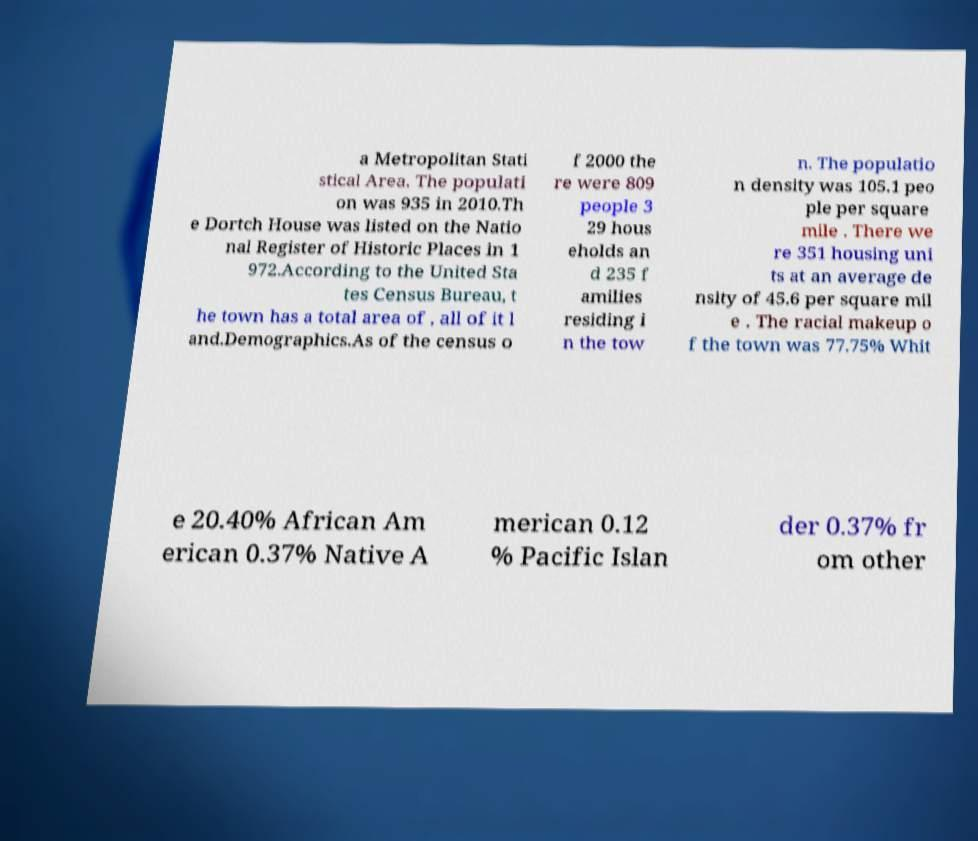Could you extract and type out the text from this image? a Metropolitan Stati stical Area. The populati on was 935 in 2010.Th e Dortch House was listed on the Natio nal Register of Historic Places in 1 972.According to the United Sta tes Census Bureau, t he town has a total area of , all of it l and.Demographics.As of the census o f 2000 the re were 809 people 3 29 hous eholds an d 235 f amilies residing i n the tow n. The populatio n density was 105.1 peo ple per square mile . There we re 351 housing uni ts at an average de nsity of 45.6 per square mil e . The racial makeup o f the town was 77.75% Whit e 20.40% African Am erican 0.37% Native A merican 0.12 % Pacific Islan der 0.37% fr om other 